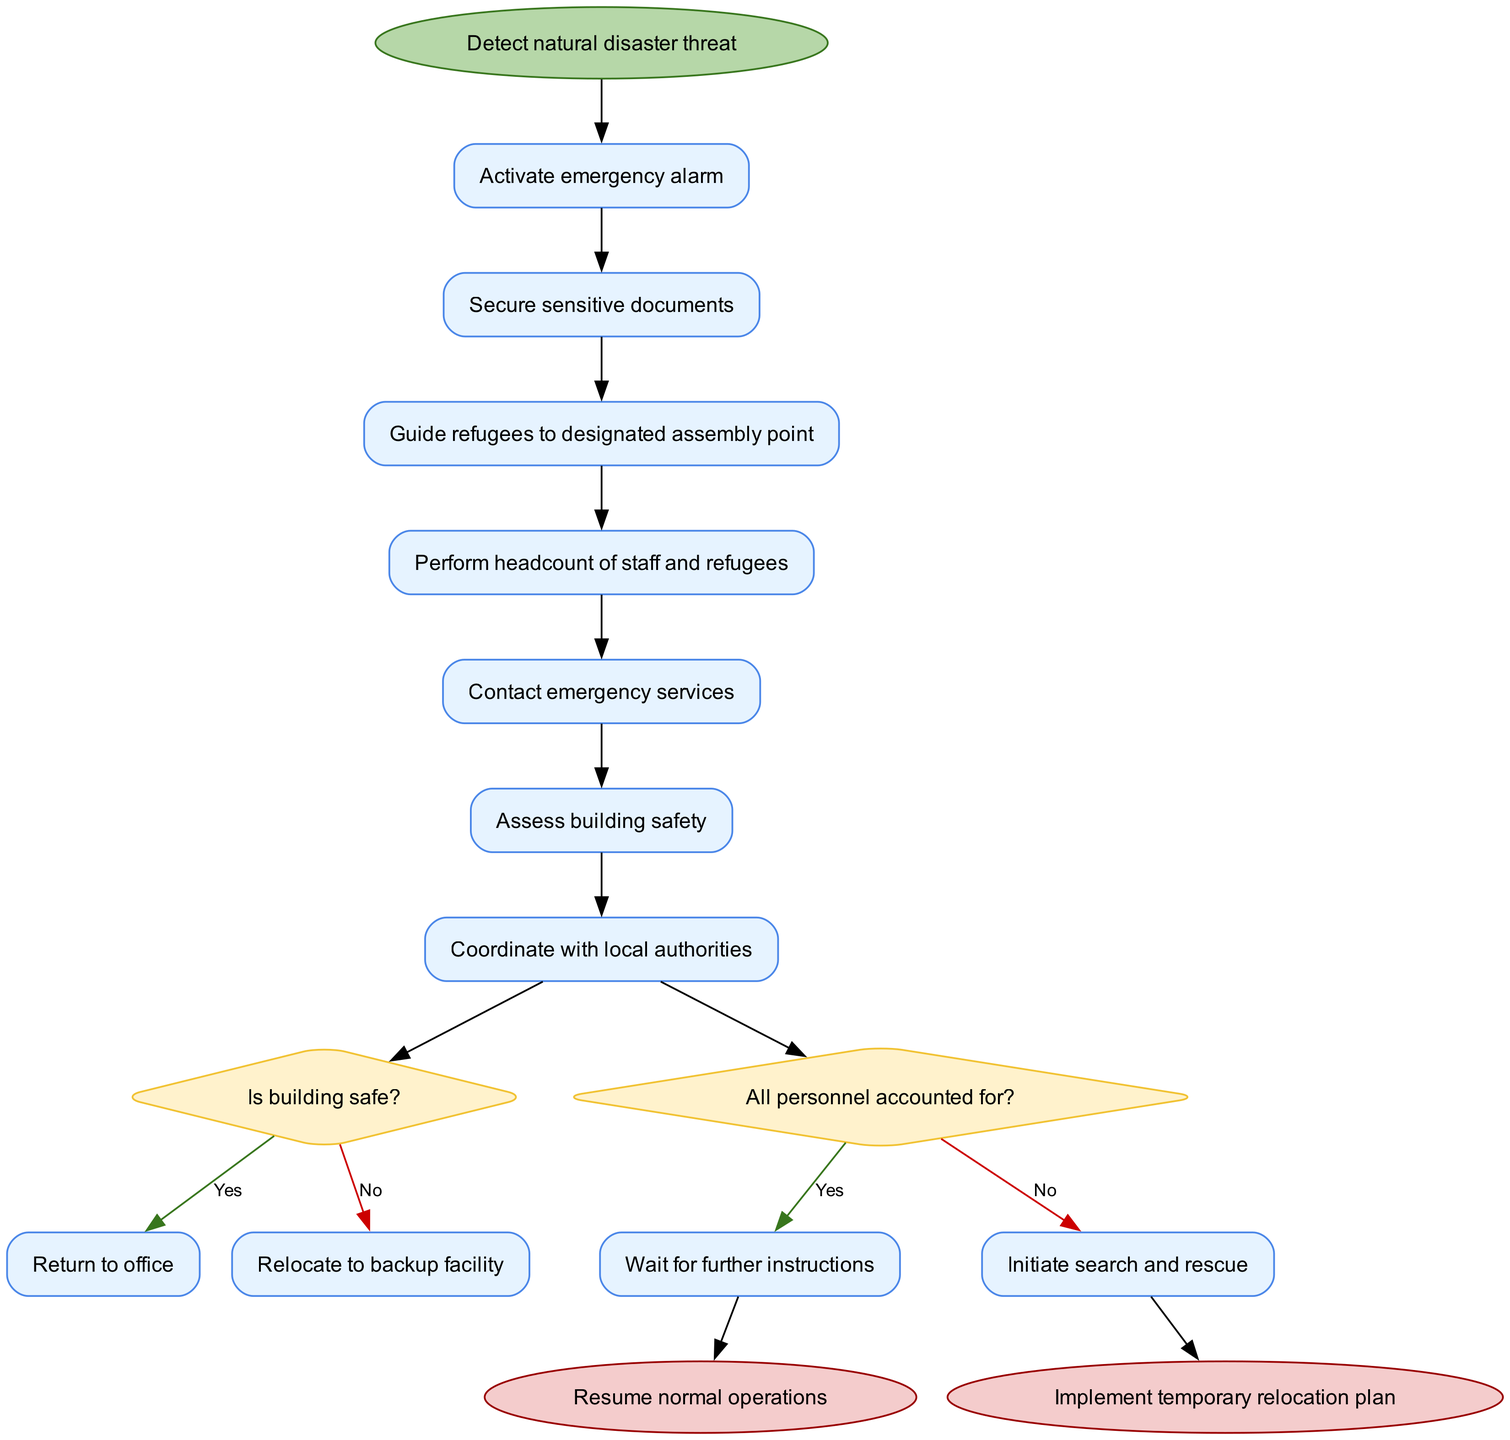What is the start node of the diagram? The start node is labeled "Detect natural disaster threat," which is the first point in the activity flow in the diagram.
Answer: Detect natural disaster threat How many activities are there in the diagram? The diagram contains a total of 6 activities listed, indicating the steps to be taken during an emergency evacuation.
Answer: 6 What is the decision question after the last activity? The decision question following the last activity is "All personnel accounted for?", which determines the next steps based on personnel status.
Answer: All personnel accounted for? If the building is safe, what is the next action? If the building is deemed safe, the process leads to the action labeled "Return to office," directing to resume normal activities after safety is confirmed.
Answer: Return to office What are the two end nodes of the diagram? The two end nodes in the diagram are "Resume normal operations" and "Implement temporary relocation plan," indicating possible outcomes after evaluating the situation.
Answer: Resume normal operations, Implement temporary relocation plan What happens if all personnel are not accounted for? If not all personnel are accounted for, the next action in the diagram is to "Initiate search and rescue," promoting efforts to locate and ensure the safety of missing individuals.
Answer: Initiate search and rescue List all the activities in order. The activities, in order, are: "Activate emergency alarm," "Secure sensitive documents," "Guide refugees to designated assembly point," "Perform headcount of staff and refugees," "Contact emergency services," and "Assess building safety."
Answer: Activate emergency alarm, Secure sensitive documents, Guide refugees to designated assembly point, Perform headcount of staff and refugees, Contact emergency services, Assess building safety What is the next step after contacting emergency services? After contacting emergency services, the flow of the diagram proceeds to "Assess building safety," where the safety of the structure is evaluated before further actions are taken.
Answer: Assess building safety 